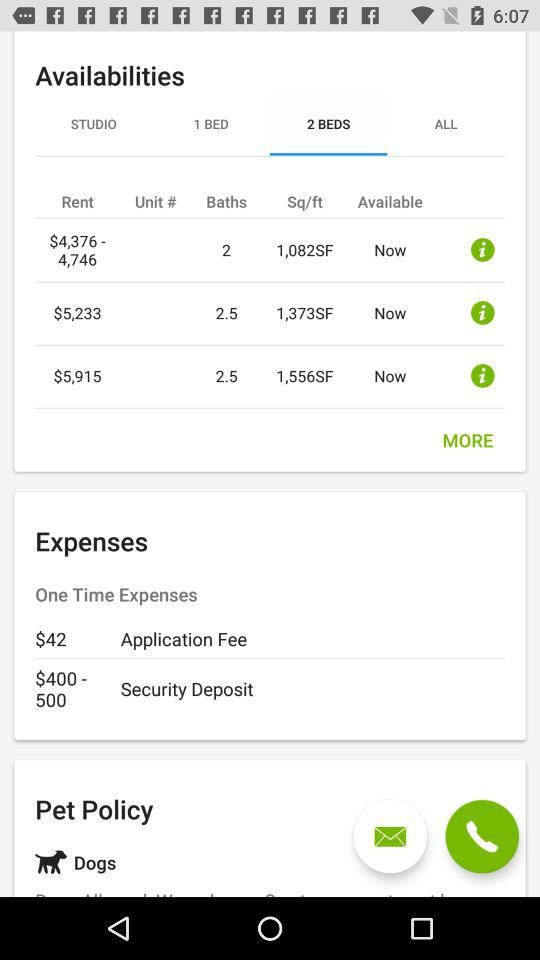What is the rent for the property whose area is 1082 SF? The rent for the property, whose area is 1082 square feet, ranges from $4,376 to $4,746. 